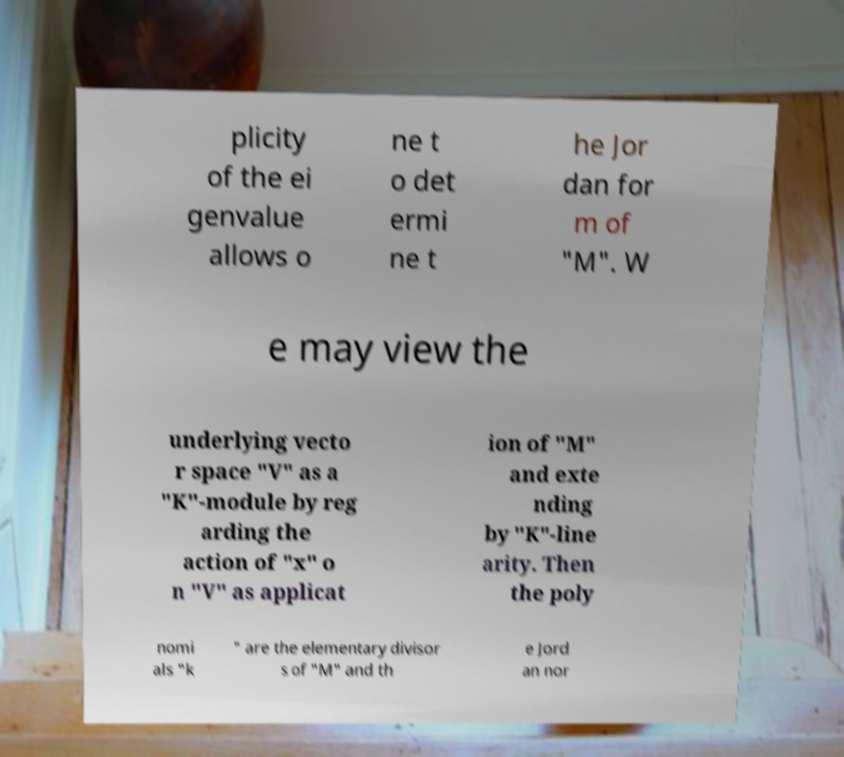There's text embedded in this image that I need extracted. Can you transcribe it verbatim? plicity of the ei genvalue allows o ne t o det ermi ne t he Jor dan for m of "M". W e may view the underlying vecto r space "V" as a "K"-module by reg arding the action of "x" o n "V" as applicat ion of "M" and exte nding by "K"-line arity. Then the poly nomi als "k " are the elementary divisor s of "M" and th e Jord an nor 